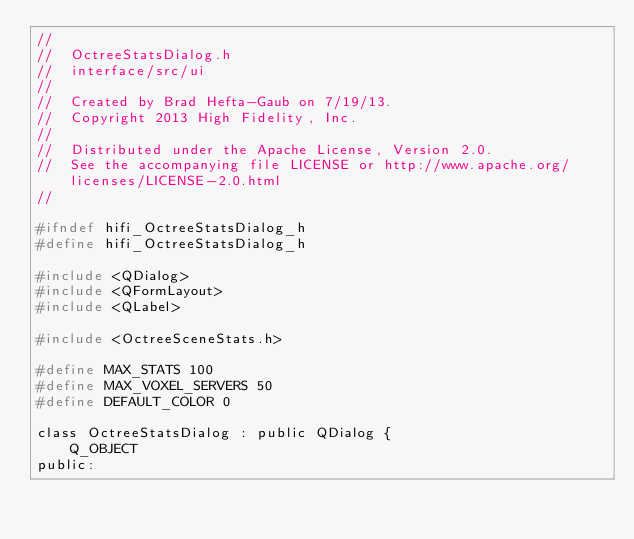Convert code to text. <code><loc_0><loc_0><loc_500><loc_500><_C_>//
//  OctreeStatsDialog.h
//  interface/src/ui
//
//  Created by Brad Hefta-Gaub on 7/19/13.
//  Copyright 2013 High Fidelity, Inc.
//
//  Distributed under the Apache License, Version 2.0.
//  See the accompanying file LICENSE or http://www.apache.org/licenses/LICENSE-2.0.html
//

#ifndef hifi_OctreeStatsDialog_h
#define hifi_OctreeStatsDialog_h

#include <QDialog>
#include <QFormLayout>
#include <QLabel>

#include <OctreeSceneStats.h>

#define MAX_STATS 100
#define MAX_VOXEL_SERVERS 50
#define DEFAULT_COLOR 0

class OctreeStatsDialog : public QDialog {
    Q_OBJECT
public:</code> 